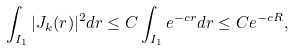<formula> <loc_0><loc_0><loc_500><loc_500>\int _ { I _ { 1 } } | J _ { k } ( r ) | ^ { 2 } d r \leq C \int _ { I _ { 1 } } e ^ { - c r } d r \leq C e ^ { - c R } ,</formula> 